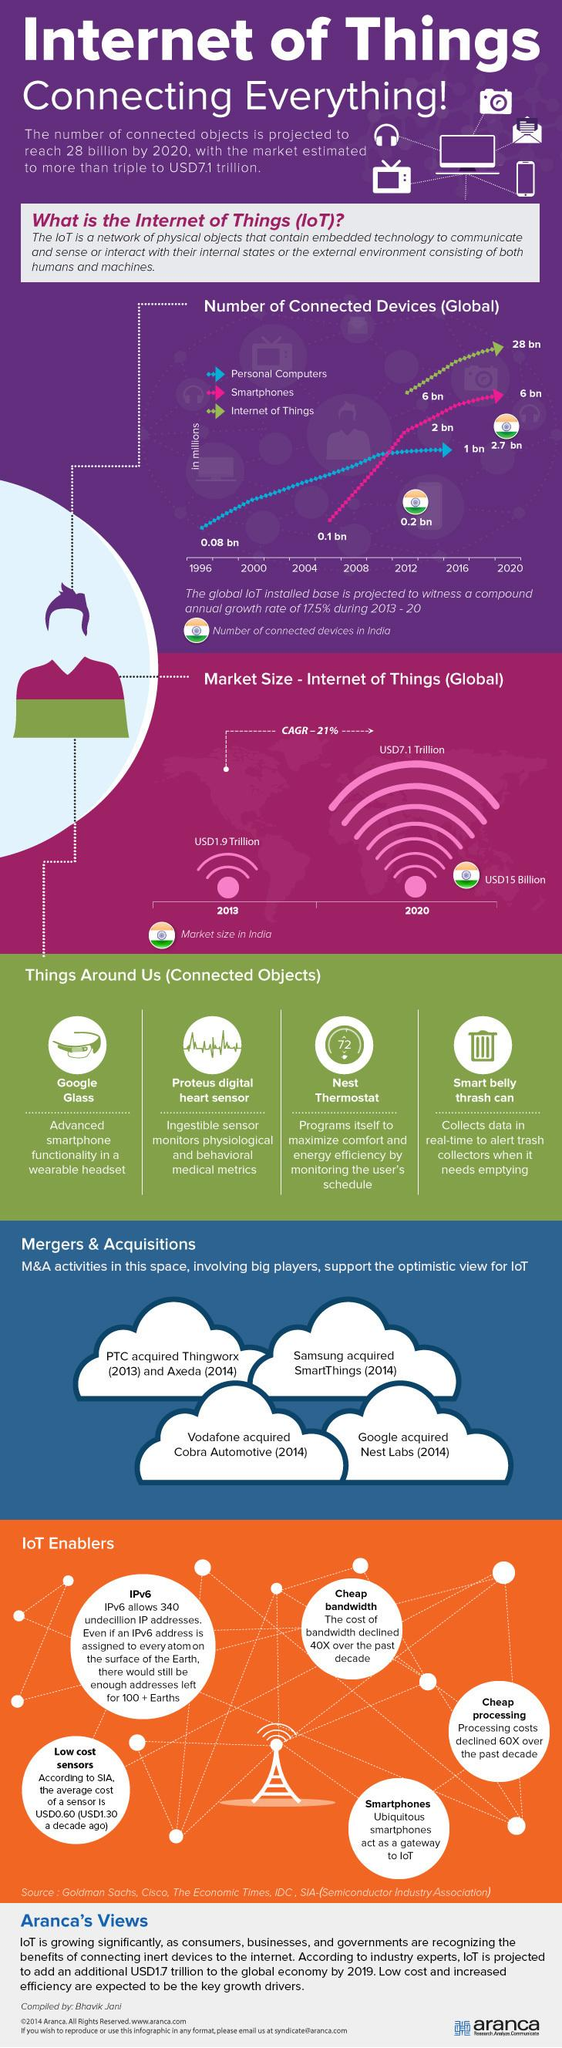Highlight a few significant elements in this photo. In 2020, there were approximately 28 billion IoT connected devices globally. By 2020, it is estimated that 6 billion smartphones will be connected to the Internet of Things (IoT). As of 2020, there were approximately 2.7 billion IoT connections in India. In 2020, the global market value of IoT was estimated to be approximately USD7.1 trillion. The market value of IoT in India is estimated to be approximately USD15 billion in 2020. 